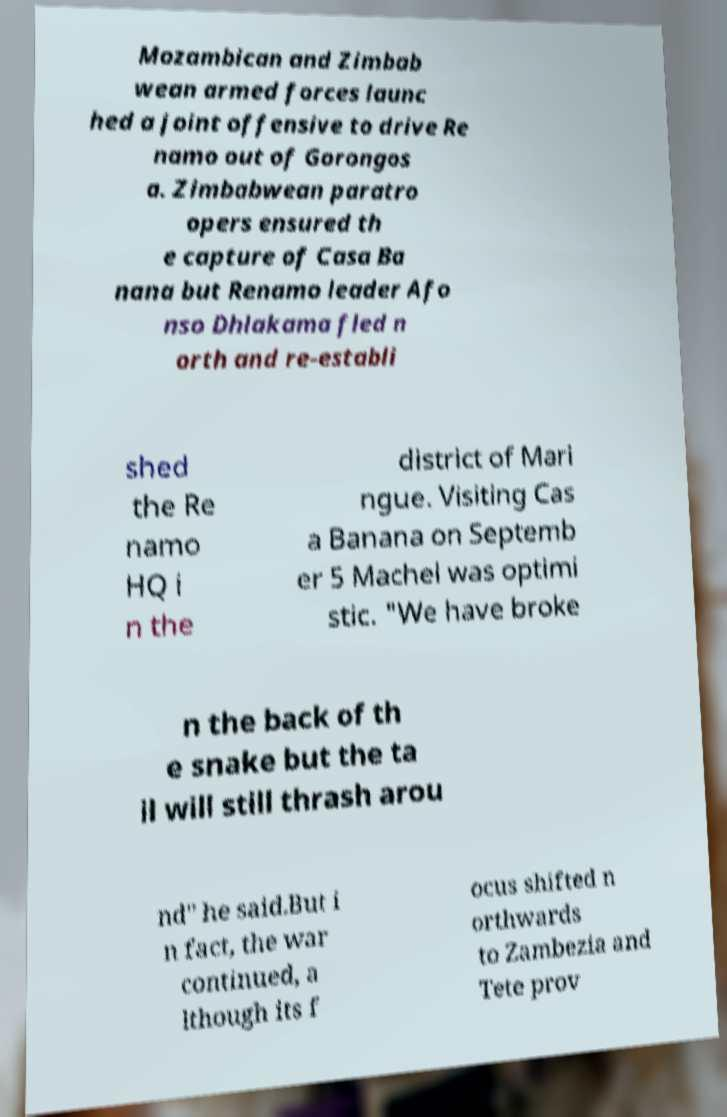I need the written content from this picture converted into text. Can you do that? Mozambican and Zimbab wean armed forces launc hed a joint offensive to drive Re namo out of Gorongos a. Zimbabwean paratro opers ensured th e capture of Casa Ba nana but Renamo leader Afo nso Dhlakama fled n orth and re-establi shed the Re namo HQ i n the district of Mari ngue. Visiting Cas a Banana on Septemb er 5 Machel was optimi stic. "We have broke n the back of th e snake but the ta il will still thrash arou nd" he said.But i n fact, the war continued, a lthough its f ocus shifted n orthwards to Zambezia and Tete prov 